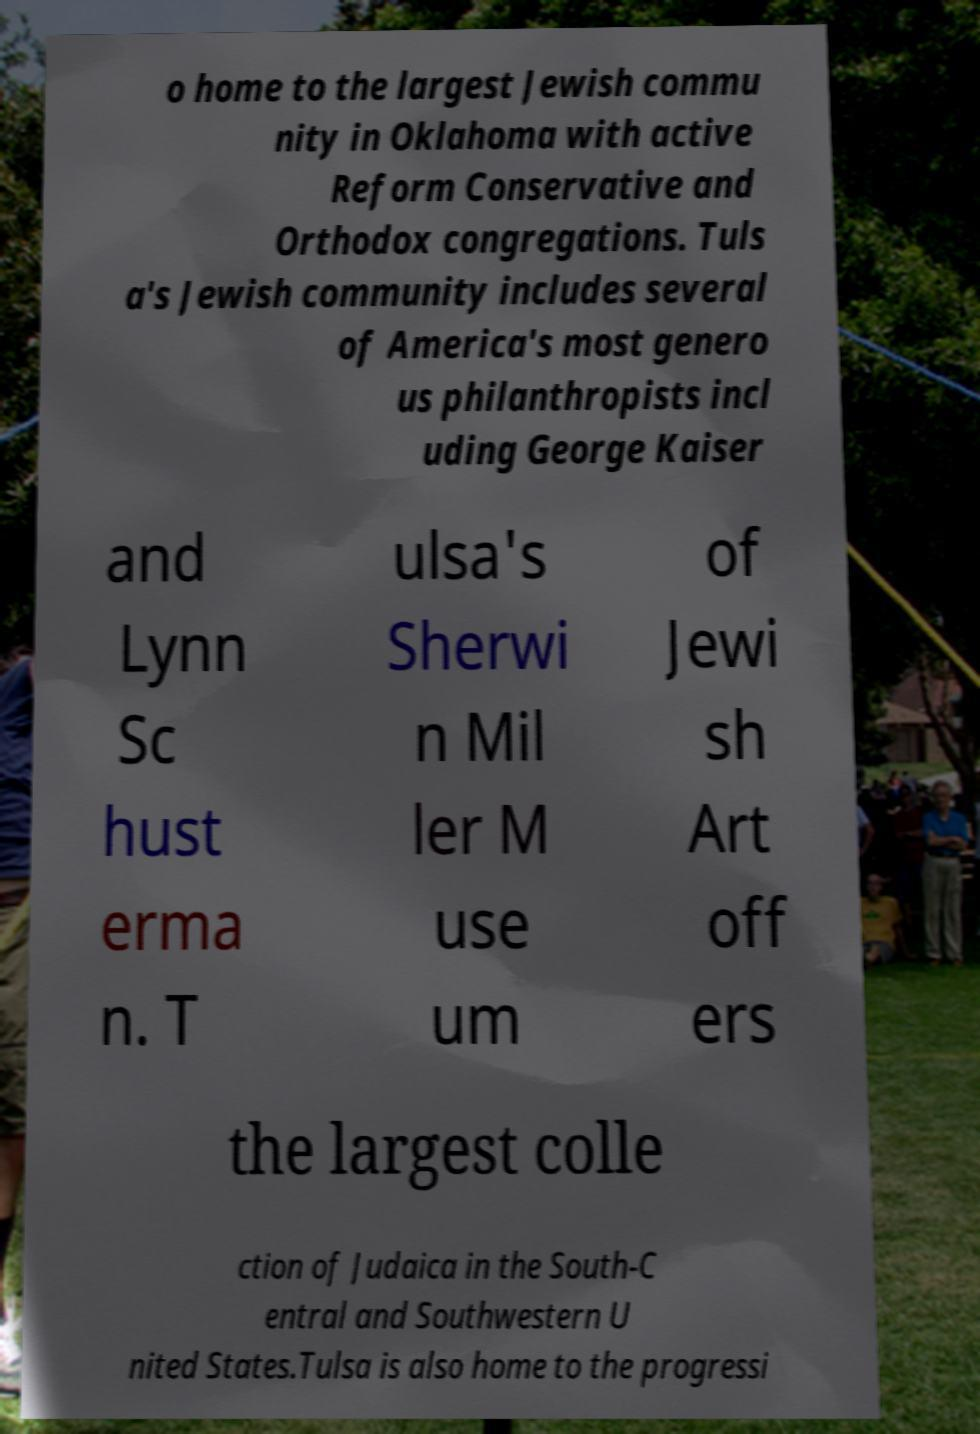Can you read and provide the text displayed in the image?This photo seems to have some interesting text. Can you extract and type it out for me? o home to the largest Jewish commu nity in Oklahoma with active Reform Conservative and Orthodox congregations. Tuls a's Jewish community includes several of America's most genero us philanthropists incl uding George Kaiser and Lynn Sc hust erma n. T ulsa's Sherwi n Mil ler M use um of Jewi sh Art off ers the largest colle ction of Judaica in the South-C entral and Southwestern U nited States.Tulsa is also home to the progressi 